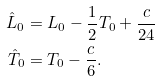Convert formula to latex. <formula><loc_0><loc_0><loc_500><loc_500>\hat { L } _ { 0 } & = L _ { 0 } - \frac { 1 } { 2 } T _ { 0 } + \frac { c } { 2 4 } \\ \hat { T } _ { 0 } & = T _ { 0 } - \frac { c } { 6 } .</formula> 